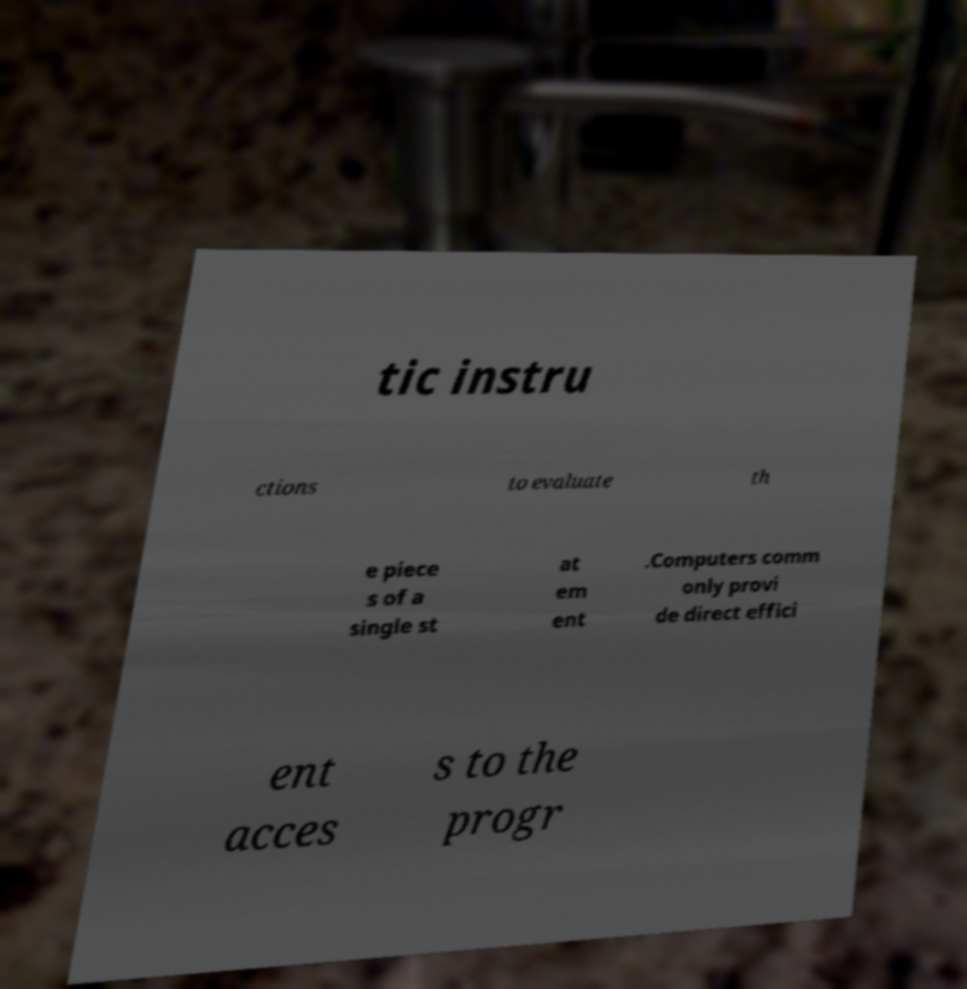There's text embedded in this image that I need extracted. Can you transcribe it verbatim? tic instru ctions to evaluate th e piece s of a single st at em ent .Computers comm only provi de direct effici ent acces s to the progr 